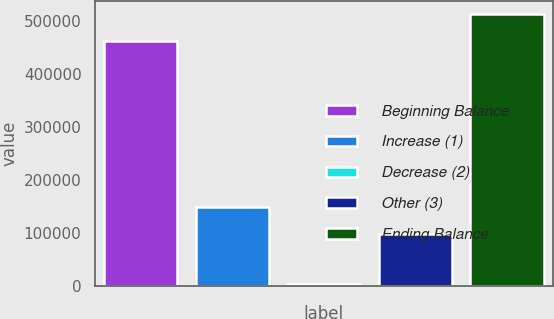Convert chart. <chart><loc_0><loc_0><loc_500><loc_500><bar_chart><fcel>Beginning Balance<fcel>Increase (1)<fcel>Decrease (2)<fcel>Other (3)<fcel>Ending Balance<nl><fcel>463018<fcel>149359<fcel>4315<fcel>99178<fcel>513199<nl></chart> 